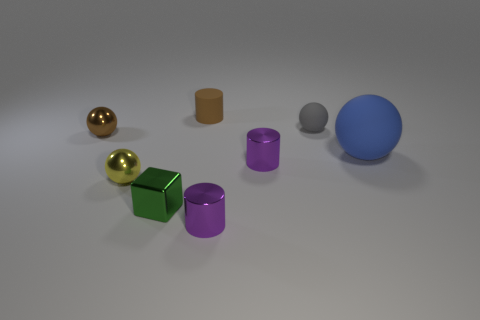Subtract all blue spheres. How many spheres are left? 3 Subtract all cylinders. How many objects are left? 5 Add 1 tiny gray rubber blocks. How many objects exist? 9 Subtract all brown cylinders. How many cylinders are left? 2 Subtract 1 spheres. How many spheres are left? 3 Subtract all green cylinders. Subtract all brown balls. How many cylinders are left? 3 Subtract all yellow cylinders. How many gray spheres are left? 1 Subtract all big cyan metallic objects. Subtract all small cylinders. How many objects are left? 5 Add 8 small brown objects. How many small brown objects are left? 10 Add 3 brown cylinders. How many brown cylinders exist? 4 